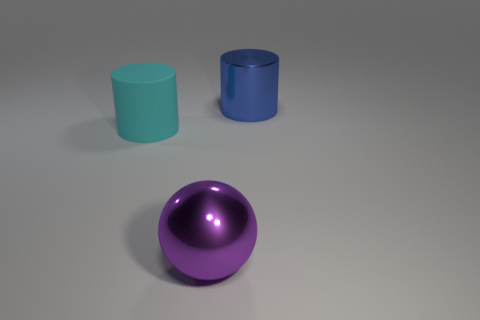Is there anything else that is made of the same material as the cyan cylinder?
Your response must be concise. No. How many objects are tiny rubber objects or big metal things that are in front of the blue metal cylinder?
Your response must be concise. 1. What material is the big thing that is behind the cylinder to the left of the shiny object to the left of the metallic cylinder?
Give a very brief answer. Metal. The purple sphere that is the same material as the big blue cylinder is what size?
Provide a succinct answer. Large. There is a large cylinder that is left of the big object that is to the right of the purple ball; what is its color?
Provide a short and direct response. Cyan. What number of cylinders are made of the same material as the blue object?
Your answer should be compact. 0. What number of metallic objects are large spheres or large cylinders?
Keep it short and to the point. 2. There is a purple thing that is the same size as the blue cylinder; what material is it?
Provide a succinct answer. Metal. Is there a thing made of the same material as the big purple sphere?
Make the answer very short. Yes. There is a object to the left of the sphere that is in front of the big cylinder behind the large rubber cylinder; what is its shape?
Give a very brief answer. Cylinder. 